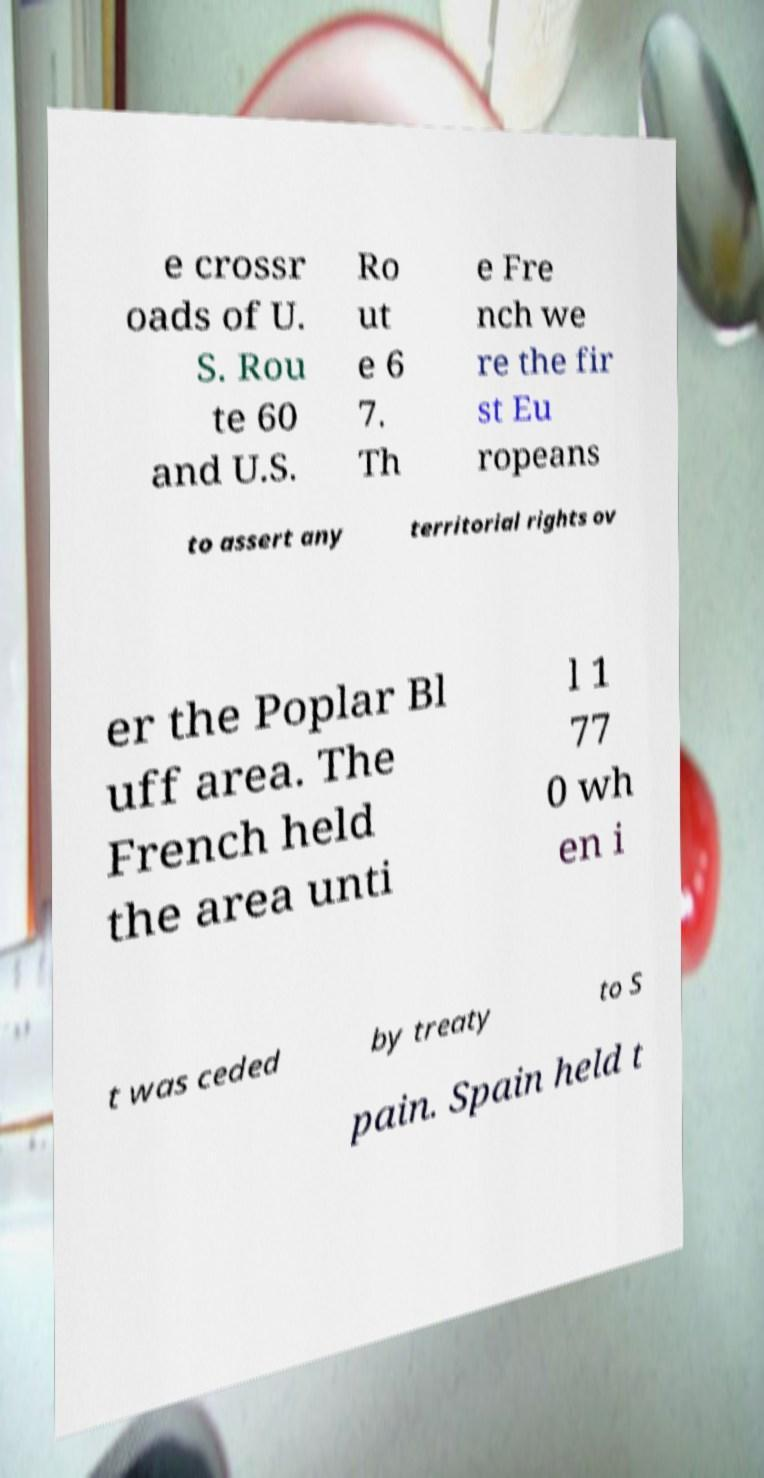What messages or text are displayed in this image? I need them in a readable, typed format. e crossr oads of U. S. Rou te 60 and U.S. Ro ut e 6 7. Th e Fre nch we re the fir st Eu ropeans to assert any territorial rights ov er the Poplar Bl uff area. The French held the area unti l 1 77 0 wh en i t was ceded by treaty to S pain. Spain held t 